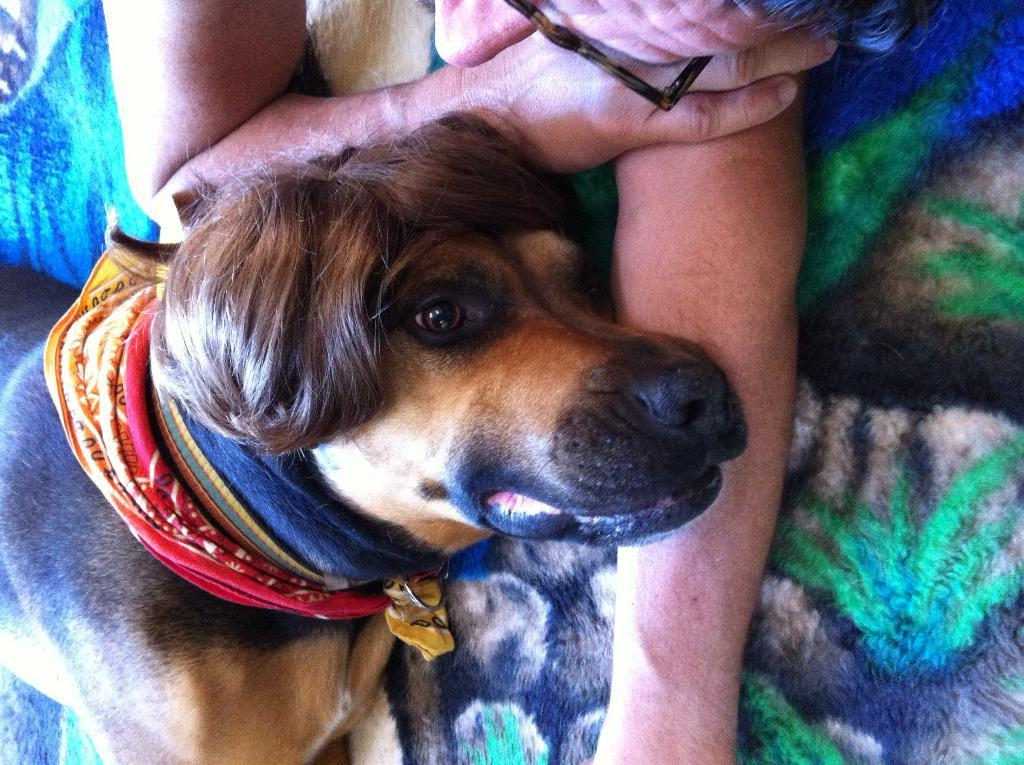What type of animal is in the image? There is a dog in the image. What color is the dog? The dog is brown in color. Can you describe the person in the background of the image? There is a person in the background of the image, and they are laying on a surface with blue and green colors. What type of door can be seen on the side of the dog in the image? There is no door present in the image, and the dog does not have a side that would allow for a door to be attached. 